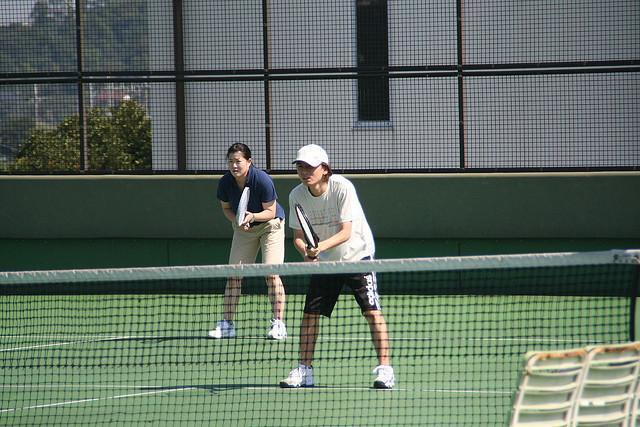How many chairs can be seen?
Give a very brief answer. 2. How many people are in the photo?
Give a very brief answer. 2. How many cars are on the road?
Give a very brief answer. 0. 